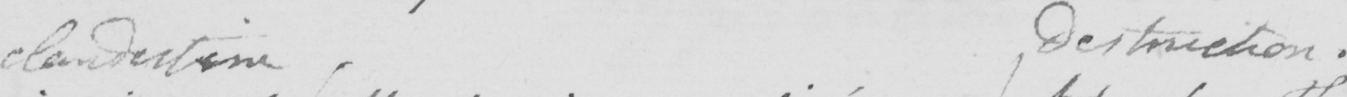Can you read and transcribe this handwriting? clandestine destruction . 